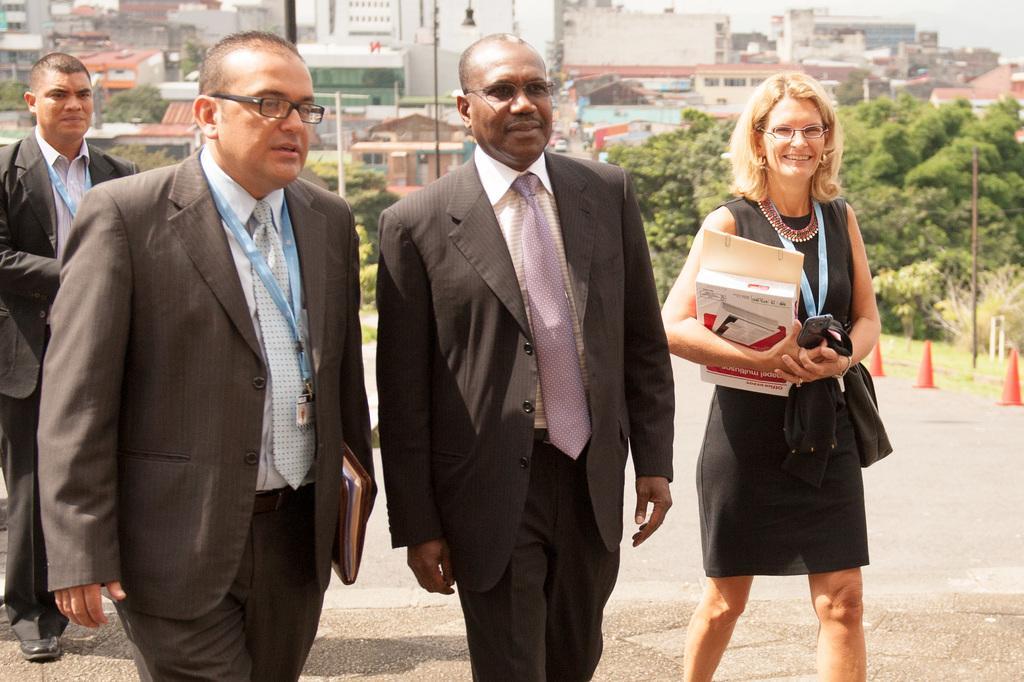Describe this image in one or two sentences. In the picture we can see two men and a woman walking and coming, men are in blazers, ties and one man is wearing a tag and ID card and the woman is holding a book, file and mobile phone and behind them, we can see a man standing in blazer, tie and ID card and beside them we can see some poles, trees, plants, houses and buildings. 